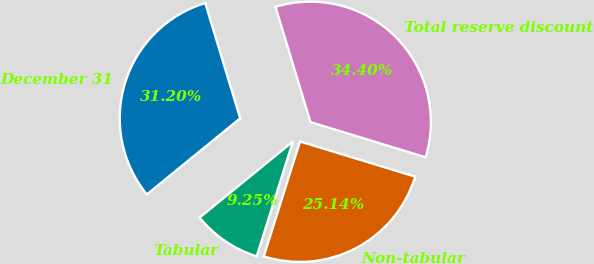Convert chart to OTSL. <chart><loc_0><loc_0><loc_500><loc_500><pie_chart><fcel>December 31<fcel>Tabular<fcel>Non-tabular<fcel>Total reserve discount<nl><fcel>31.2%<fcel>9.25%<fcel>25.14%<fcel>34.4%<nl></chart> 